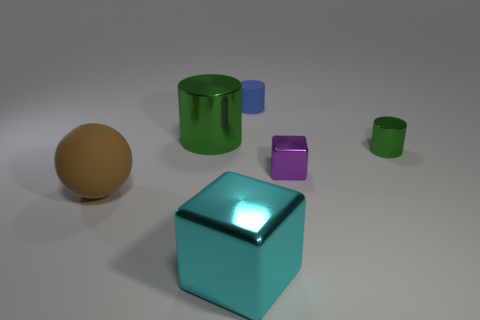How many other objects are there of the same color as the big rubber ball?
Your answer should be very brief. 0. Is the green object that is to the left of the tiny green cylinder made of the same material as the brown sphere?
Provide a short and direct response. No. Is the number of large shiny cubes that are on the right side of the small blue thing less than the number of small green cylinders right of the tiny purple object?
Ensure brevity in your answer.  Yes. How many other objects are there of the same material as the big cylinder?
Your answer should be very brief. 3. What is the material of the green thing that is the same size as the cyan metal block?
Provide a short and direct response. Metal. Are there fewer blue things on the right side of the blue rubber cylinder than small purple shiny cubes?
Ensure brevity in your answer.  Yes. What is the shape of the rubber thing right of the green metal cylinder that is behind the shiny cylinder that is to the right of the small purple thing?
Offer a very short reply. Cylinder. There is a matte object that is in front of the big cylinder; how big is it?
Give a very brief answer. Large. The green thing that is the same size as the blue cylinder is what shape?
Keep it short and to the point. Cylinder. How many things are either small cyan spheres or metallic blocks that are behind the big block?
Your answer should be compact. 1. 